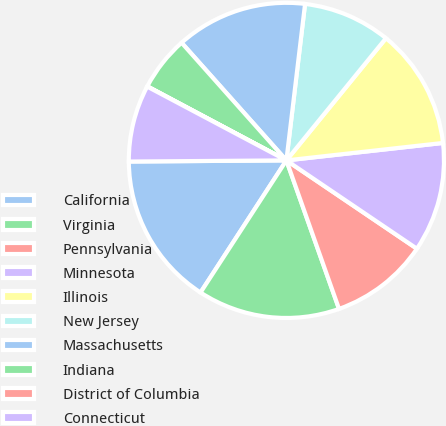Convert chart to OTSL. <chart><loc_0><loc_0><loc_500><loc_500><pie_chart><fcel>California<fcel>Virginia<fcel>Pennsylvania<fcel>Minnesota<fcel>Illinois<fcel>New Jersey<fcel>Massachusetts<fcel>Indiana<fcel>District of Columbia<fcel>Connecticut<nl><fcel>15.71%<fcel>14.59%<fcel>10.11%<fcel>11.23%<fcel>12.35%<fcel>8.99%<fcel>13.47%<fcel>5.63%<fcel>0.03%<fcel>7.87%<nl></chart> 